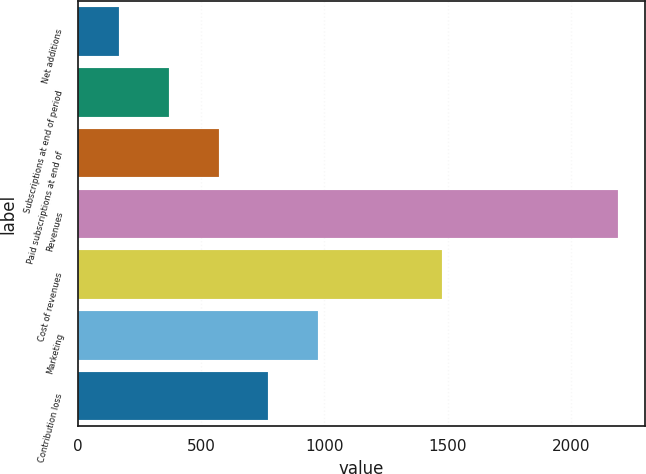Convert chart to OTSL. <chart><loc_0><loc_0><loc_500><loc_500><bar_chart><fcel>Net additions<fcel>Subscriptions at end of period<fcel>Paid subscriptions at end of<fcel>Revenues<fcel>Cost of revenues<fcel>Marketing<fcel>Contribution loss<nl><fcel>165<fcel>367.6<fcel>570.2<fcel>2191<fcel>1478<fcel>975.4<fcel>772.8<nl></chart> 